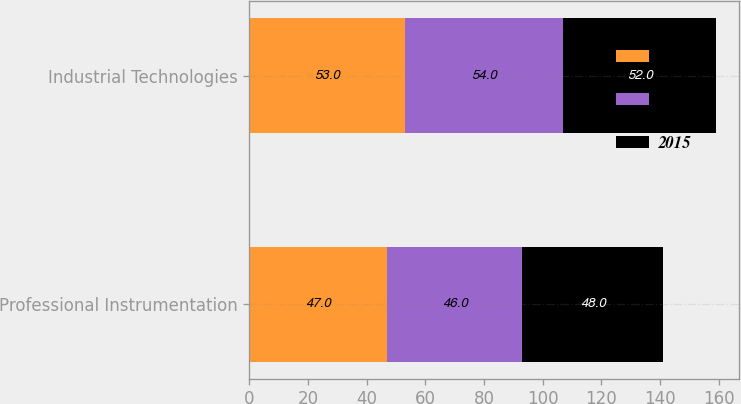Convert chart to OTSL. <chart><loc_0><loc_0><loc_500><loc_500><stacked_bar_chart><ecel><fcel>Professional Instrumentation<fcel>Industrial Technologies<nl><fcel>2017<fcel>47<fcel>53<nl><fcel>2016<fcel>46<fcel>54<nl><fcel>2015<fcel>48<fcel>52<nl></chart> 